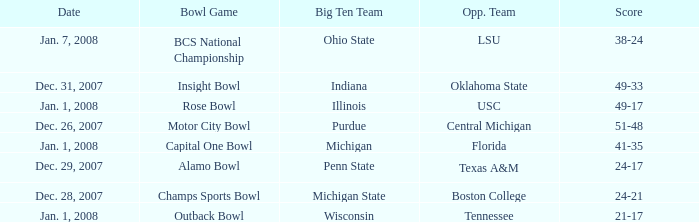What bowl game was played on Dec. 26, 2007? Motor City Bowl. 